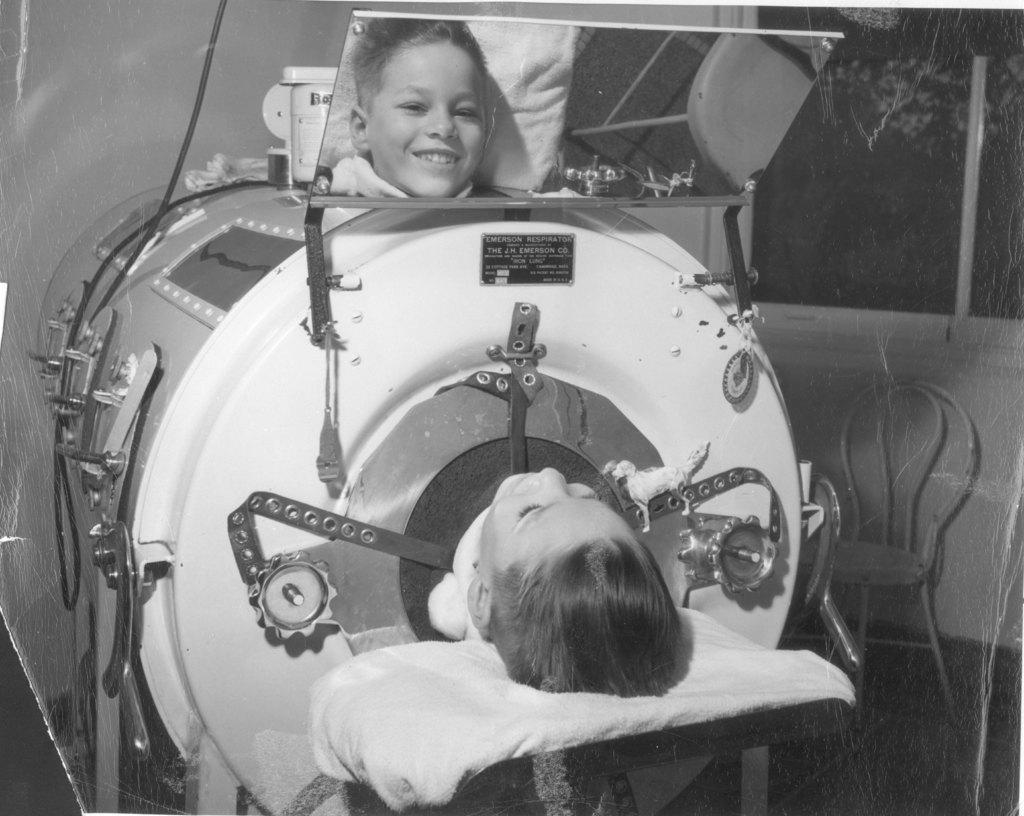In one or two sentences, can you explain what this image depicts? In this picture I can see a boy lying and I can see mirror and I can see reflection of a boy in the mirror and it looks like a scanning machine. 